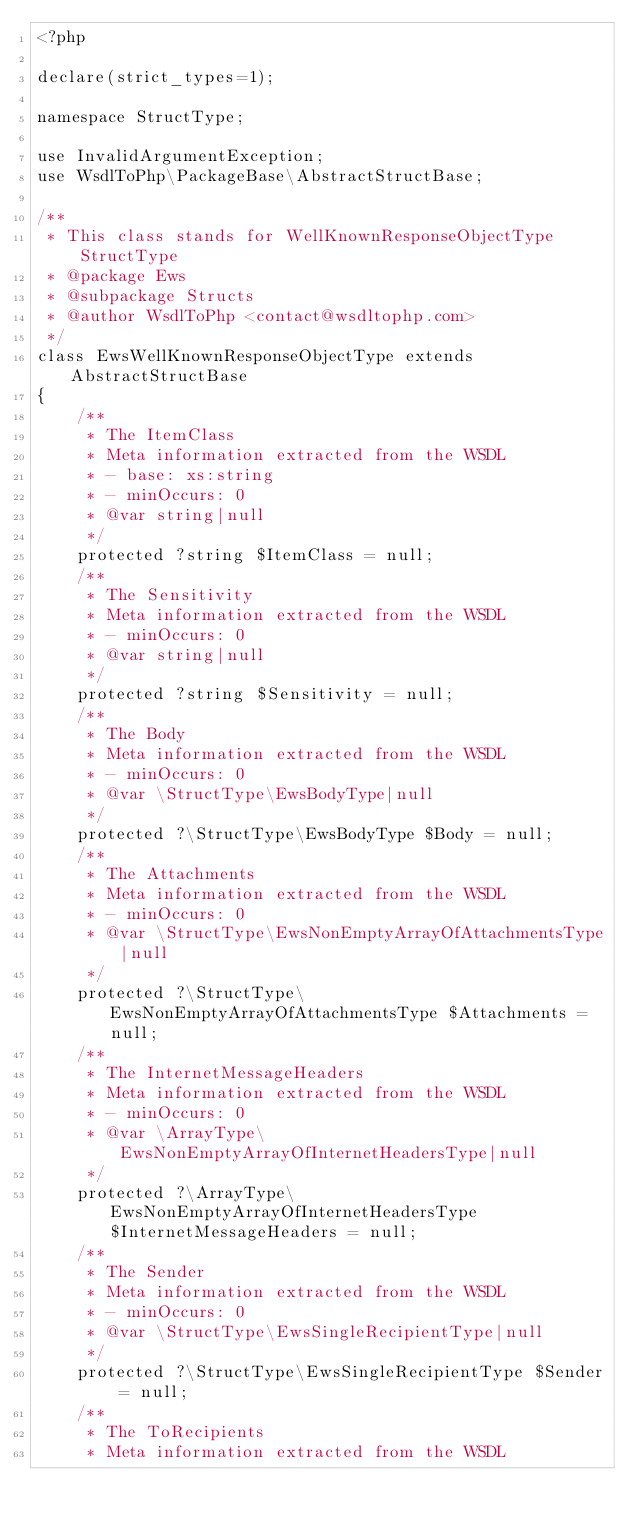<code> <loc_0><loc_0><loc_500><loc_500><_PHP_><?php

declare(strict_types=1);

namespace StructType;

use InvalidArgumentException;
use WsdlToPhp\PackageBase\AbstractStructBase;

/**
 * This class stands for WellKnownResponseObjectType StructType
 * @package Ews
 * @subpackage Structs
 * @author WsdlToPhp <contact@wsdltophp.com>
 */
class EwsWellKnownResponseObjectType extends AbstractStructBase
{
    /**
     * The ItemClass
     * Meta information extracted from the WSDL
     * - base: xs:string
     * - minOccurs: 0
     * @var string|null
     */
    protected ?string $ItemClass = null;
    /**
     * The Sensitivity
     * Meta information extracted from the WSDL
     * - minOccurs: 0
     * @var string|null
     */
    protected ?string $Sensitivity = null;
    /**
     * The Body
     * Meta information extracted from the WSDL
     * - minOccurs: 0
     * @var \StructType\EwsBodyType|null
     */
    protected ?\StructType\EwsBodyType $Body = null;
    /**
     * The Attachments
     * Meta information extracted from the WSDL
     * - minOccurs: 0
     * @var \StructType\EwsNonEmptyArrayOfAttachmentsType|null
     */
    protected ?\StructType\EwsNonEmptyArrayOfAttachmentsType $Attachments = null;
    /**
     * The InternetMessageHeaders
     * Meta information extracted from the WSDL
     * - minOccurs: 0
     * @var \ArrayType\EwsNonEmptyArrayOfInternetHeadersType|null
     */
    protected ?\ArrayType\EwsNonEmptyArrayOfInternetHeadersType $InternetMessageHeaders = null;
    /**
     * The Sender
     * Meta information extracted from the WSDL
     * - minOccurs: 0
     * @var \StructType\EwsSingleRecipientType|null
     */
    protected ?\StructType\EwsSingleRecipientType $Sender = null;
    /**
     * The ToRecipients
     * Meta information extracted from the WSDL</code> 